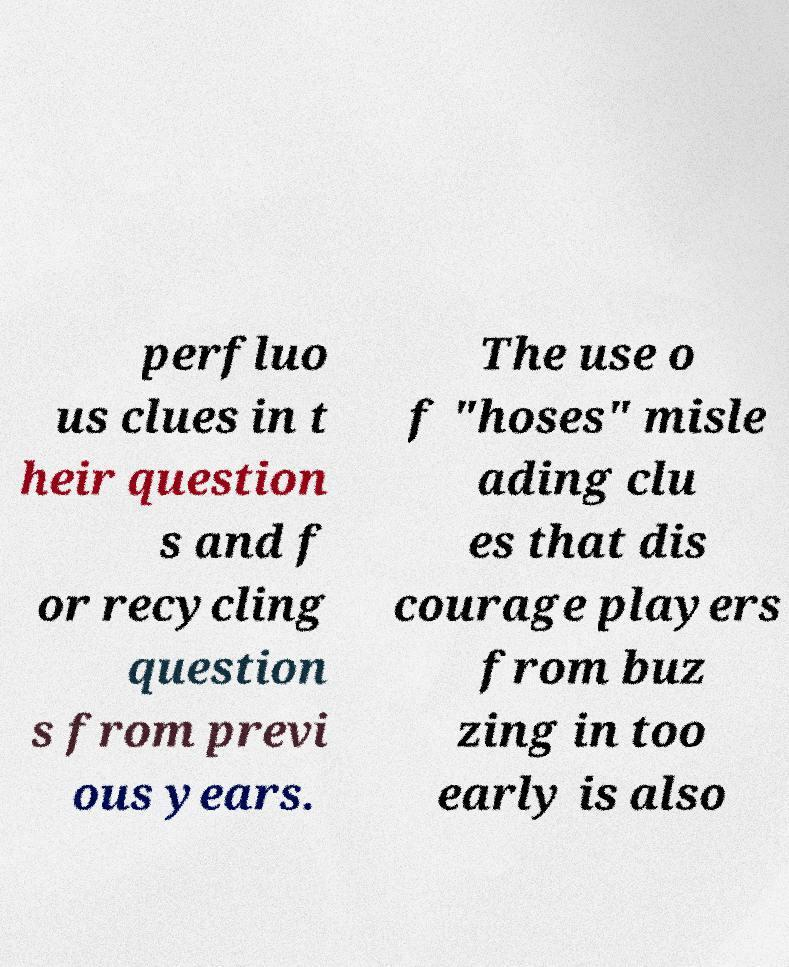There's text embedded in this image that I need extracted. Can you transcribe it verbatim? perfluo us clues in t heir question s and f or recycling question s from previ ous years. The use o f "hoses" misle ading clu es that dis courage players from buz zing in too early is also 